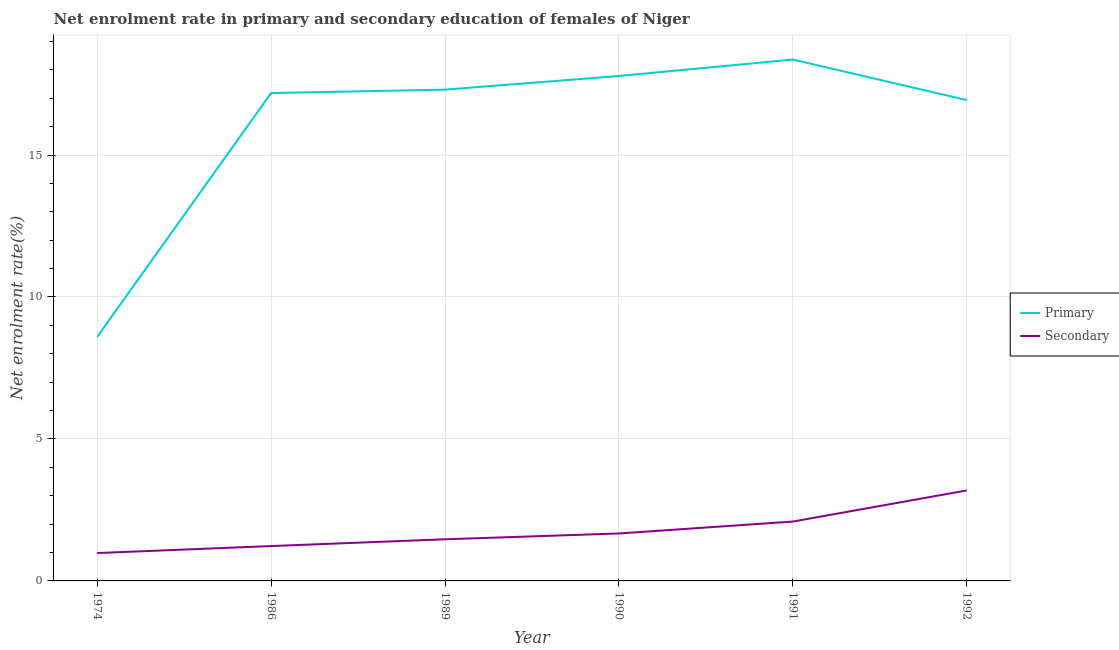What is the enrollment rate in primary education in 1989?
Your response must be concise. 17.3. Across all years, what is the maximum enrollment rate in secondary education?
Your answer should be compact. 3.19. Across all years, what is the minimum enrollment rate in secondary education?
Your response must be concise. 0.98. In which year was the enrollment rate in secondary education maximum?
Your response must be concise. 1992. In which year was the enrollment rate in primary education minimum?
Make the answer very short. 1974. What is the total enrollment rate in secondary education in the graph?
Keep it short and to the point. 10.62. What is the difference between the enrollment rate in secondary education in 1974 and that in 1991?
Your answer should be very brief. -1.11. What is the difference between the enrollment rate in secondary education in 1992 and the enrollment rate in primary education in 1990?
Your response must be concise. -14.6. What is the average enrollment rate in secondary education per year?
Offer a terse response. 1.77. In the year 1986, what is the difference between the enrollment rate in secondary education and enrollment rate in primary education?
Offer a terse response. -15.96. What is the ratio of the enrollment rate in secondary education in 1974 to that in 1990?
Keep it short and to the point. 0.59. What is the difference between the highest and the second highest enrollment rate in primary education?
Your answer should be very brief. 0.58. What is the difference between the highest and the lowest enrollment rate in secondary education?
Provide a short and direct response. 2.21. In how many years, is the enrollment rate in primary education greater than the average enrollment rate in primary education taken over all years?
Your answer should be very brief. 5. Is the sum of the enrollment rate in primary education in 1974 and 1989 greater than the maximum enrollment rate in secondary education across all years?
Keep it short and to the point. Yes. Is the enrollment rate in primary education strictly greater than the enrollment rate in secondary education over the years?
Keep it short and to the point. Yes. How many lines are there?
Give a very brief answer. 2. Does the graph contain any zero values?
Your answer should be very brief. No. Where does the legend appear in the graph?
Ensure brevity in your answer.  Center right. How many legend labels are there?
Ensure brevity in your answer.  2. How are the legend labels stacked?
Ensure brevity in your answer.  Vertical. What is the title of the graph?
Your answer should be very brief. Net enrolment rate in primary and secondary education of females of Niger. What is the label or title of the Y-axis?
Your response must be concise. Net enrolment rate(%). What is the Net enrolment rate(%) in Primary in 1974?
Provide a short and direct response. 8.6. What is the Net enrolment rate(%) of Secondary in 1974?
Your response must be concise. 0.98. What is the Net enrolment rate(%) of Primary in 1986?
Offer a very short reply. 17.18. What is the Net enrolment rate(%) in Secondary in 1986?
Keep it short and to the point. 1.23. What is the Net enrolment rate(%) in Primary in 1989?
Offer a very short reply. 17.3. What is the Net enrolment rate(%) of Secondary in 1989?
Your response must be concise. 1.47. What is the Net enrolment rate(%) in Primary in 1990?
Keep it short and to the point. 17.78. What is the Net enrolment rate(%) of Secondary in 1990?
Give a very brief answer. 1.67. What is the Net enrolment rate(%) in Primary in 1991?
Give a very brief answer. 18.36. What is the Net enrolment rate(%) in Secondary in 1991?
Provide a succinct answer. 2.09. What is the Net enrolment rate(%) in Primary in 1992?
Your response must be concise. 16.94. What is the Net enrolment rate(%) in Secondary in 1992?
Provide a short and direct response. 3.19. Across all years, what is the maximum Net enrolment rate(%) in Primary?
Offer a very short reply. 18.36. Across all years, what is the maximum Net enrolment rate(%) of Secondary?
Offer a terse response. 3.19. Across all years, what is the minimum Net enrolment rate(%) in Primary?
Offer a very short reply. 8.6. Across all years, what is the minimum Net enrolment rate(%) of Secondary?
Offer a terse response. 0.98. What is the total Net enrolment rate(%) of Primary in the graph?
Make the answer very short. 96.17. What is the total Net enrolment rate(%) in Secondary in the graph?
Give a very brief answer. 10.62. What is the difference between the Net enrolment rate(%) of Primary in 1974 and that in 1986?
Keep it short and to the point. -8.59. What is the difference between the Net enrolment rate(%) in Secondary in 1974 and that in 1986?
Your answer should be very brief. -0.25. What is the difference between the Net enrolment rate(%) of Primary in 1974 and that in 1989?
Give a very brief answer. -8.71. What is the difference between the Net enrolment rate(%) of Secondary in 1974 and that in 1989?
Give a very brief answer. -0.48. What is the difference between the Net enrolment rate(%) of Primary in 1974 and that in 1990?
Make the answer very short. -9.19. What is the difference between the Net enrolment rate(%) of Secondary in 1974 and that in 1990?
Make the answer very short. -0.69. What is the difference between the Net enrolment rate(%) of Primary in 1974 and that in 1991?
Your response must be concise. -9.77. What is the difference between the Net enrolment rate(%) in Secondary in 1974 and that in 1991?
Keep it short and to the point. -1.11. What is the difference between the Net enrolment rate(%) in Primary in 1974 and that in 1992?
Provide a succinct answer. -8.34. What is the difference between the Net enrolment rate(%) in Secondary in 1974 and that in 1992?
Offer a very short reply. -2.21. What is the difference between the Net enrolment rate(%) in Primary in 1986 and that in 1989?
Keep it short and to the point. -0.12. What is the difference between the Net enrolment rate(%) in Secondary in 1986 and that in 1989?
Keep it short and to the point. -0.24. What is the difference between the Net enrolment rate(%) in Primary in 1986 and that in 1990?
Provide a short and direct response. -0.6. What is the difference between the Net enrolment rate(%) of Secondary in 1986 and that in 1990?
Offer a very short reply. -0.44. What is the difference between the Net enrolment rate(%) of Primary in 1986 and that in 1991?
Provide a succinct answer. -1.18. What is the difference between the Net enrolment rate(%) in Secondary in 1986 and that in 1991?
Keep it short and to the point. -0.86. What is the difference between the Net enrolment rate(%) in Primary in 1986 and that in 1992?
Offer a very short reply. 0.25. What is the difference between the Net enrolment rate(%) in Secondary in 1986 and that in 1992?
Ensure brevity in your answer.  -1.96. What is the difference between the Net enrolment rate(%) in Primary in 1989 and that in 1990?
Keep it short and to the point. -0.48. What is the difference between the Net enrolment rate(%) of Secondary in 1989 and that in 1990?
Make the answer very short. -0.21. What is the difference between the Net enrolment rate(%) of Primary in 1989 and that in 1991?
Offer a terse response. -1.06. What is the difference between the Net enrolment rate(%) of Secondary in 1989 and that in 1991?
Give a very brief answer. -0.62. What is the difference between the Net enrolment rate(%) of Primary in 1989 and that in 1992?
Provide a short and direct response. 0.37. What is the difference between the Net enrolment rate(%) of Secondary in 1989 and that in 1992?
Provide a short and direct response. -1.72. What is the difference between the Net enrolment rate(%) in Primary in 1990 and that in 1991?
Give a very brief answer. -0.58. What is the difference between the Net enrolment rate(%) of Secondary in 1990 and that in 1991?
Provide a short and direct response. -0.42. What is the difference between the Net enrolment rate(%) in Primary in 1990 and that in 1992?
Provide a succinct answer. 0.85. What is the difference between the Net enrolment rate(%) in Secondary in 1990 and that in 1992?
Your response must be concise. -1.52. What is the difference between the Net enrolment rate(%) in Primary in 1991 and that in 1992?
Your answer should be very brief. 1.43. What is the difference between the Net enrolment rate(%) of Secondary in 1991 and that in 1992?
Ensure brevity in your answer.  -1.1. What is the difference between the Net enrolment rate(%) of Primary in 1974 and the Net enrolment rate(%) of Secondary in 1986?
Give a very brief answer. 7.37. What is the difference between the Net enrolment rate(%) of Primary in 1974 and the Net enrolment rate(%) of Secondary in 1989?
Your answer should be compact. 7.13. What is the difference between the Net enrolment rate(%) in Primary in 1974 and the Net enrolment rate(%) in Secondary in 1990?
Make the answer very short. 6.92. What is the difference between the Net enrolment rate(%) in Primary in 1974 and the Net enrolment rate(%) in Secondary in 1991?
Your answer should be very brief. 6.5. What is the difference between the Net enrolment rate(%) in Primary in 1974 and the Net enrolment rate(%) in Secondary in 1992?
Ensure brevity in your answer.  5.41. What is the difference between the Net enrolment rate(%) of Primary in 1986 and the Net enrolment rate(%) of Secondary in 1989?
Provide a succinct answer. 15.72. What is the difference between the Net enrolment rate(%) in Primary in 1986 and the Net enrolment rate(%) in Secondary in 1990?
Keep it short and to the point. 15.51. What is the difference between the Net enrolment rate(%) in Primary in 1986 and the Net enrolment rate(%) in Secondary in 1991?
Your response must be concise. 15.09. What is the difference between the Net enrolment rate(%) of Primary in 1986 and the Net enrolment rate(%) of Secondary in 1992?
Ensure brevity in your answer.  14. What is the difference between the Net enrolment rate(%) in Primary in 1989 and the Net enrolment rate(%) in Secondary in 1990?
Your answer should be compact. 15.63. What is the difference between the Net enrolment rate(%) in Primary in 1989 and the Net enrolment rate(%) in Secondary in 1991?
Your answer should be compact. 15.21. What is the difference between the Net enrolment rate(%) in Primary in 1989 and the Net enrolment rate(%) in Secondary in 1992?
Ensure brevity in your answer.  14.12. What is the difference between the Net enrolment rate(%) in Primary in 1990 and the Net enrolment rate(%) in Secondary in 1991?
Ensure brevity in your answer.  15.69. What is the difference between the Net enrolment rate(%) of Primary in 1990 and the Net enrolment rate(%) of Secondary in 1992?
Offer a terse response. 14.6. What is the difference between the Net enrolment rate(%) of Primary in 1991 and the Net enrolment rate(%) of Secondary in 1992?
Give a very brief answer. 15.18. What is the average Net enrolment rate(%) in Primary per year?
Ensure brevity in your answer.  16.03. What is the average Net enrolment rate(%) in Secondary per year?
Your answer should be compact. 1.77. In the year 1974, what is the difference between the Net enrolment rate(%) of Primary and Net enrolment rate(%) of Secondary?
Give a very brief answer. 7.61. In the year 1986, what is the difference between the Net enrolment rate(%) in Primary and Net enrolment rate(%) in Secondary?
Your answer should be very brief. 15.96. In the year 1989, what is the difference between the Net enrolment rate(%) of Primary and Net enrolment rate(%) of Secondary?
Keep it short and to the point. 15.84. In the year 1990, what is the difference between the Net enrolment rate(%) of Primary and Net enrolment rate(%) of Secondary?
Provide a short and direct response. 16.11. In the year 1991, what is the difference between the Net enrolment rate(%) of Primary and Net enrolment rate(%) of Secondary?
Your answer should be compact. 16.27. In the year 1992, what is the difference between the Net enrolment rate(%) of Primary and Net enrolment rate(%) of Secondary?
Provide a succinct answer. 13.75. What is the ratio of the Net enrolment rate(%) in Primary in 1974 to that in 1986?
Give a very brief answer. 0.5. What is the ratio of the Net enrolment rate(%) in Secondary in 1974 to that in 1986?
Provide a short and direct response. 0.8. What is the ratio of the Net enrolment rate(%) of Primary in 1974 to that in 1989?
Make the answer very short. 0.5. What is the ratio of the Net enrolment rate(%) of Secondary in 1974 to that in 1989?
Provide a succinct answer. 0.67. What is the ratio of the Net enrolment rate(%) in Primary in 1974 to that in 1990?
Provide a short and direct response. 0.48. What is the ratio of the Net enrolment rate(%) of Secondary in 1974 to that in 1990?
Your response must be concise. 0.59. What is the ratio of the Net enrolment rate(%) of Primary in 1974 to that in 1991?
Provide a short and direct response. 0.47. What is the ratio of the Net enrolment rate(%) of Secondary in 1974 to that in 1991?
Your response must be concise. 0.47. What is the ratio of the Net enrolment rate(%) of Primary in 1974 to that in 1992?
Provide a succinct answer. 0.51. What is the ratio of the Net enrolment rate(%) of Secondary in 1974 to that in 1992?
Offer a terse response. 0.31. What is the ratio of the Net enrolment rate(%) in Primary in 1986 to that in 1989?
Give a very brief answer. 0.99. What is the ratio of the Net enrolment rate(%) of Secondary in 1986 to that in 1989?
Keep it short and to the point. 0.84. What is the ratio of the Net enrolment rate(%) in Primary in 1986 to that in 1990?
Offer a very short reply. 0.97. What is the ratio of the Net enrolment rate(%) in Secondary in 1986 to that in 1990?
Your answer should be compact. 0.73. What is the ratio of the Net enrolment rate(%) of Primary in 1986 to that in 1991?
Make the answer very short. 0.94. What is the ratio of the Net enrolment rate(%) of Secondary in 1986 to that in 1991?
Give a very brief answer. 0.59. What is the ratio of the Net enrolment rate(%) in Primary in 1986 to that in 1992?
Make the answer very short. 1.01. What is the ratio of the Net enrolment rate(%) in Secondary in 1986 to that in 1992?
Provide a succinct answer. 0.39. What is the ratio of the Net enrolment rate(%) in Primary in 1989 to that in 1990?
Ensure brevity in your answer.  0.97. What is the ratio of the Net enrolment rate(%) in Secondary in 1989 to that in 1990?
Offer a very short reply. 0.88. What is the ratio of the Net enrolment rate(%) in Primary in 1989 to that in 1991?
Offer a terse response. 0.94. What is the ratio of the Net enrolment rate(%) of Secondary in 1989 to that in 1991?
Provide a short and direct response. 0.7. What is the ratio of the Net enrolment rate(%) of Primary in 1989 to that in 1992?
Offer a very short reply. 1.02. What is the ratio of the Net enrolment rate(%) in Secondary in 1989 to that in 1992?
Ensure brevity in your answer.  0.46. What is the ratio of the Net enrolment rate(%) in Primary in 1990 to that in 1991?
Give a very brief answer. 0.97. What is the ratio of the Net enrolment rate(%) in Secondary in 1990 to that in 1991?
Provide a succinct answer. 0.8. What is the ratio of the Net enrolment rate(%) of Primary in 1990 to that in 1992?
Your answer should be very brief. 1.05. What is the ratio of the Net enrolment rate(%) in Secondary in 1990 to that in 1992?
Offer a very short reply. 0.52. What is the ratio of the Net enrolment rate(%) in Primary in 1991 to that in 1992?
Your answer should be compact. 1.08. What is the ratio of the Net enrolment rate(%) of Secondary in 1991 to that in 1992?
Your response must be concise. 0.66. What is the difference between the highest and the second highest Net enrolment rate(%) in Primary?
Give a very brief answer. 0.58. What is the difference between the highest and the second highest Net enrolment rate(%) of Secondary?
Give a very brief answer. 1.1. What is the difference between the highest and the lowest Net enrolment rate(%) of Primary?
Offer a very short reply. 9.77. What is the difference between the highest and the lowest Net enrolment rate(%) in Secondary?
Offer a terse response. 2.21. 